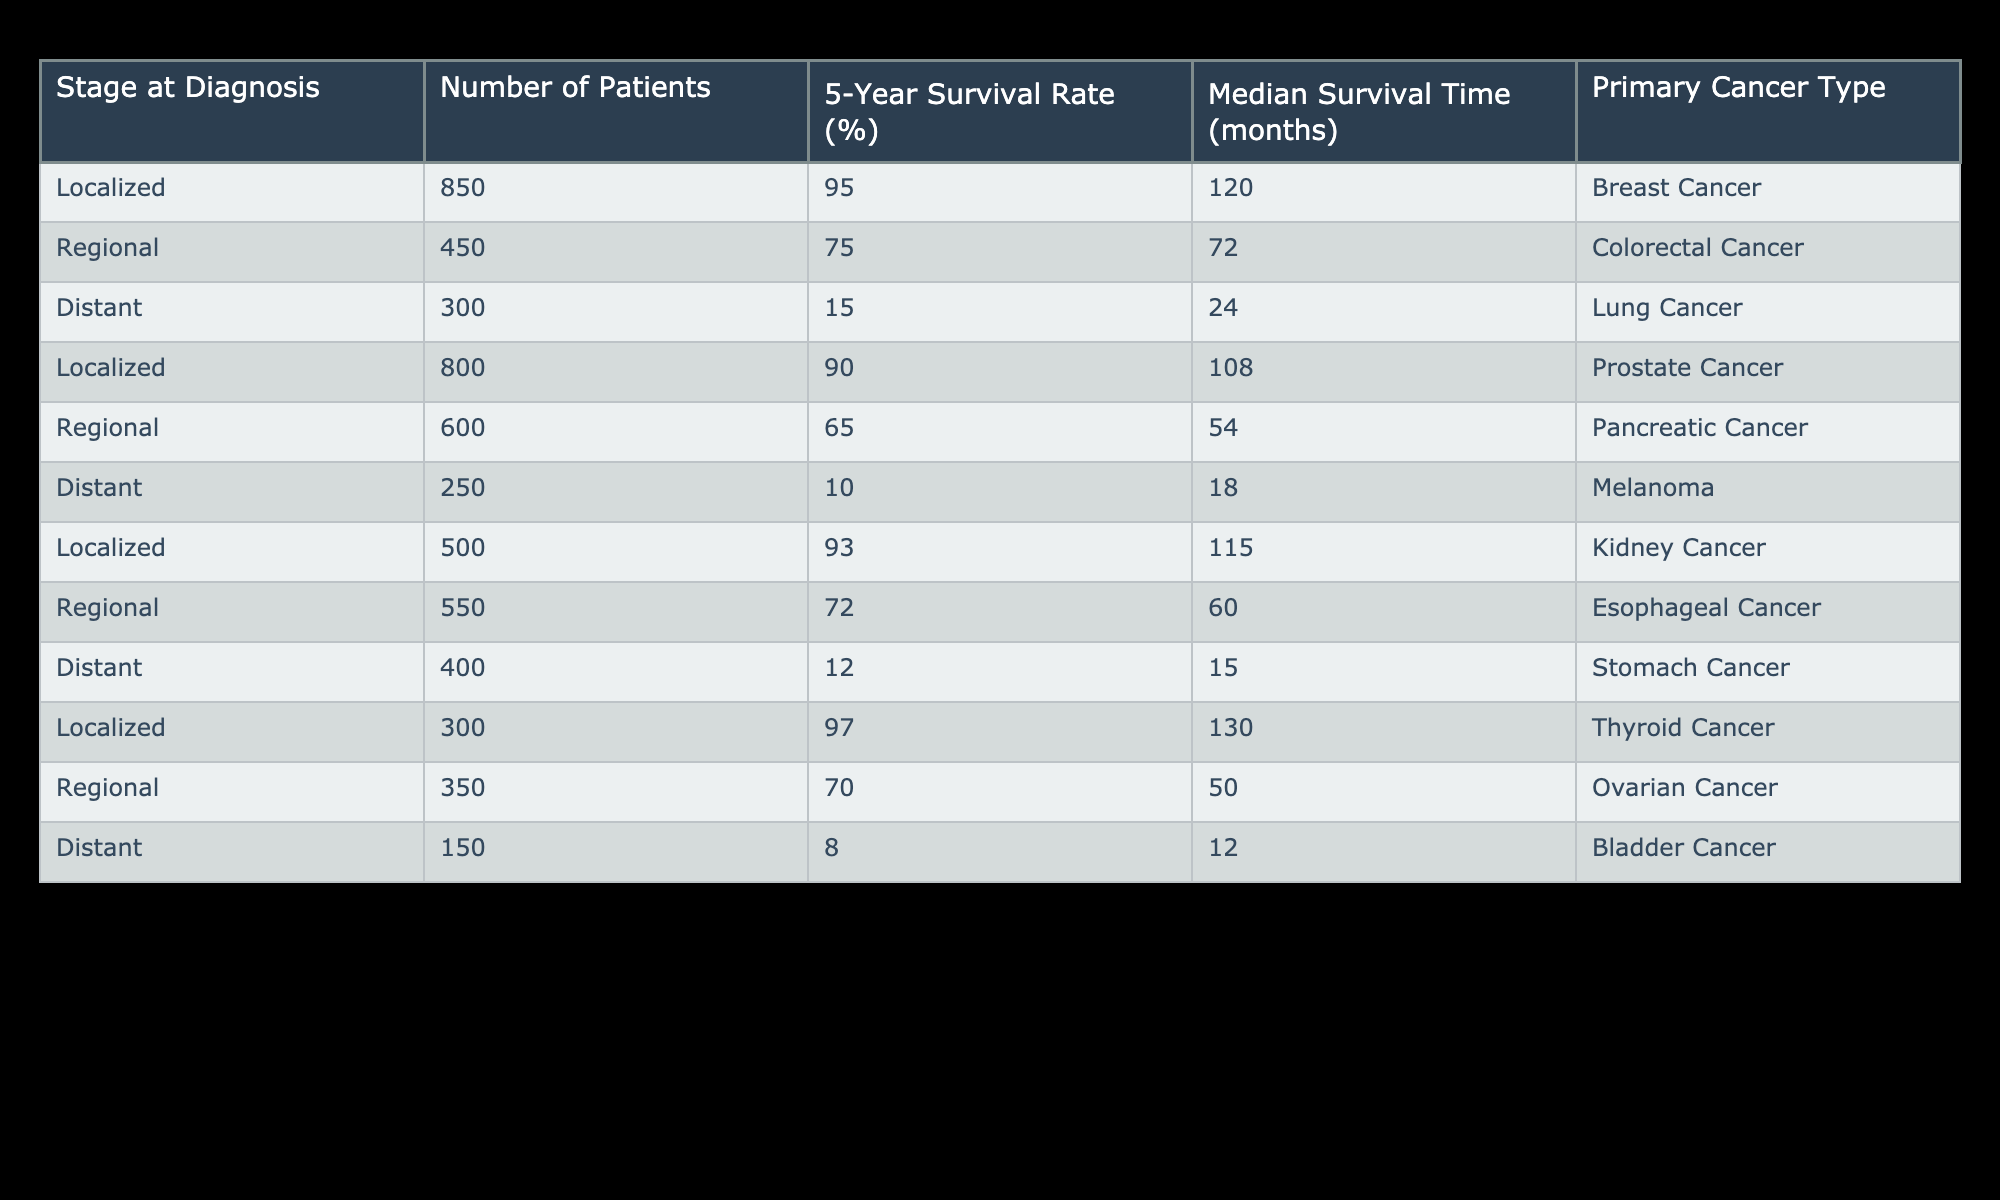What is the 5-year survival rate for patients diagnosed with localized breast cancer? The 5-year survival rate for localized breast cancer is listed in the table as 95%.
Answer: 95% How many patients are diagnosed with distant melanoma? The number of patients diagnosed with distant melanoma is provided in the table as 250.
Answer: 250 What stage has the highest median survival time, and what is that time? By reviewing the median survival times for each stage, localized cancer has the highest median survival time of 120 months (for breast cancer).
Answer: Localized; 120 months What is the difference in the number of patients diagnosed at regional versus distant stages? For regional cancer, there are 450 patients, and for distant cancer, there are 300 patients. Subtracting these, the difference is 450 - 300 = 150 patients.
Answer: 150 Is the 5-year survival rate for regional colorectal cancer higher than 70%? The 5-year survival rate for regional colorectal cancer is specified in the table as 75%, which is indeed higher than 70%.
Answer: Yes What is the average median survival time for localized cancer types listed in the table? The median survival times for localized types (breast, prostate, kidney, and thyroid cancer) are 120, 108, 115, and 130 months. Calculating the average: (120 + 108 + 115 + 130) / 4 = 118.25 months.
Answer: 118.25 months What percentage of patients with distant bladder cancer survive for 5 years? The table indicates that the 5-year survival rate for distant bladder cancer is 8%.
Answer: 8% Which stage has a lower average survival rate, regional or distant cancers? The average survival rate for regional cancers (75% for colorectal, 65% for pancreatic, 72% for esophageal, and 70% for ovarian) is (75 + 65 + 72 + 70) / 4 = 72%. For distant cancers (15% for lung, 10% for melanoma, 12% for stomach, and 8% for bladder), it is (15 + 10 + 12 + 8) / 4 = 11.25%. Comparing these averages shows that distant cancers have a lower average survival rate.
Answer: Distant cancers How many total patients were diagnosed with localized cancer types combined? The table lists patients diagnosed with localized cancers as follows: breast (850), prostate (800), kidney (500), and thyroid (300). Summing these gives 850 + 800 + 500 + 300 = 2450 patients diagnosed with localized cancer types.
Answer: 2450 